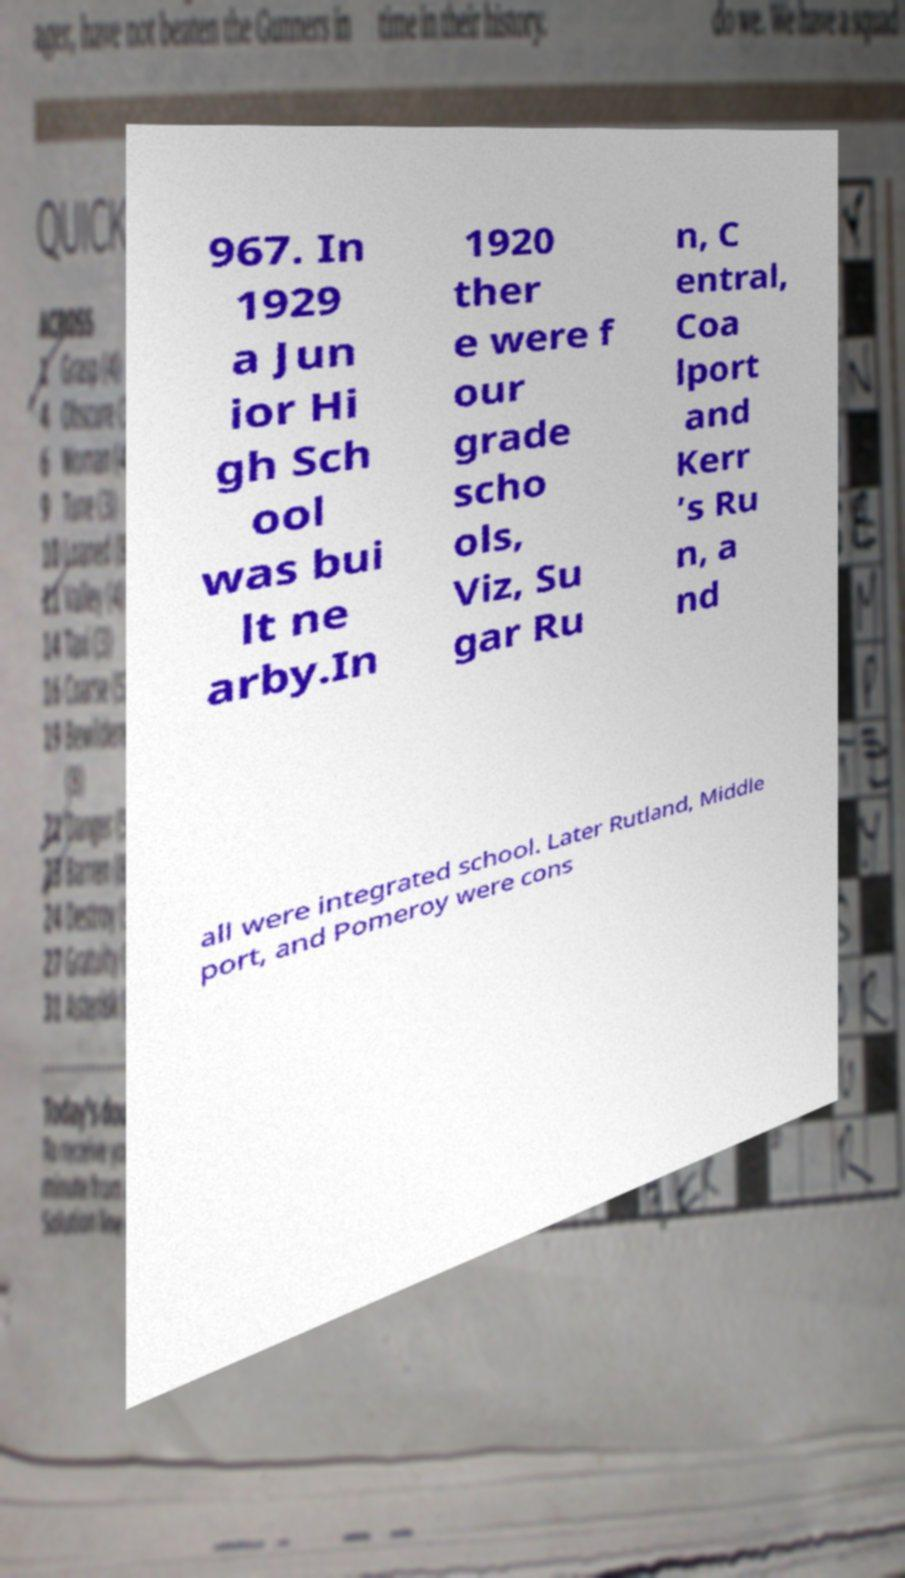Please read and relay the text visible in this image. What does it say? 967. In 1929 a Jun ior Hi gh Sch ool was bui lt ne arby.In 1920 ther e were f our grade scho ols, Viz, Su gar Ru n, C entral, Coa lport and Kerr ’s Ru n, a nd all were integrated school. Later Rutland, Middle port, and Pomeroy were cons 